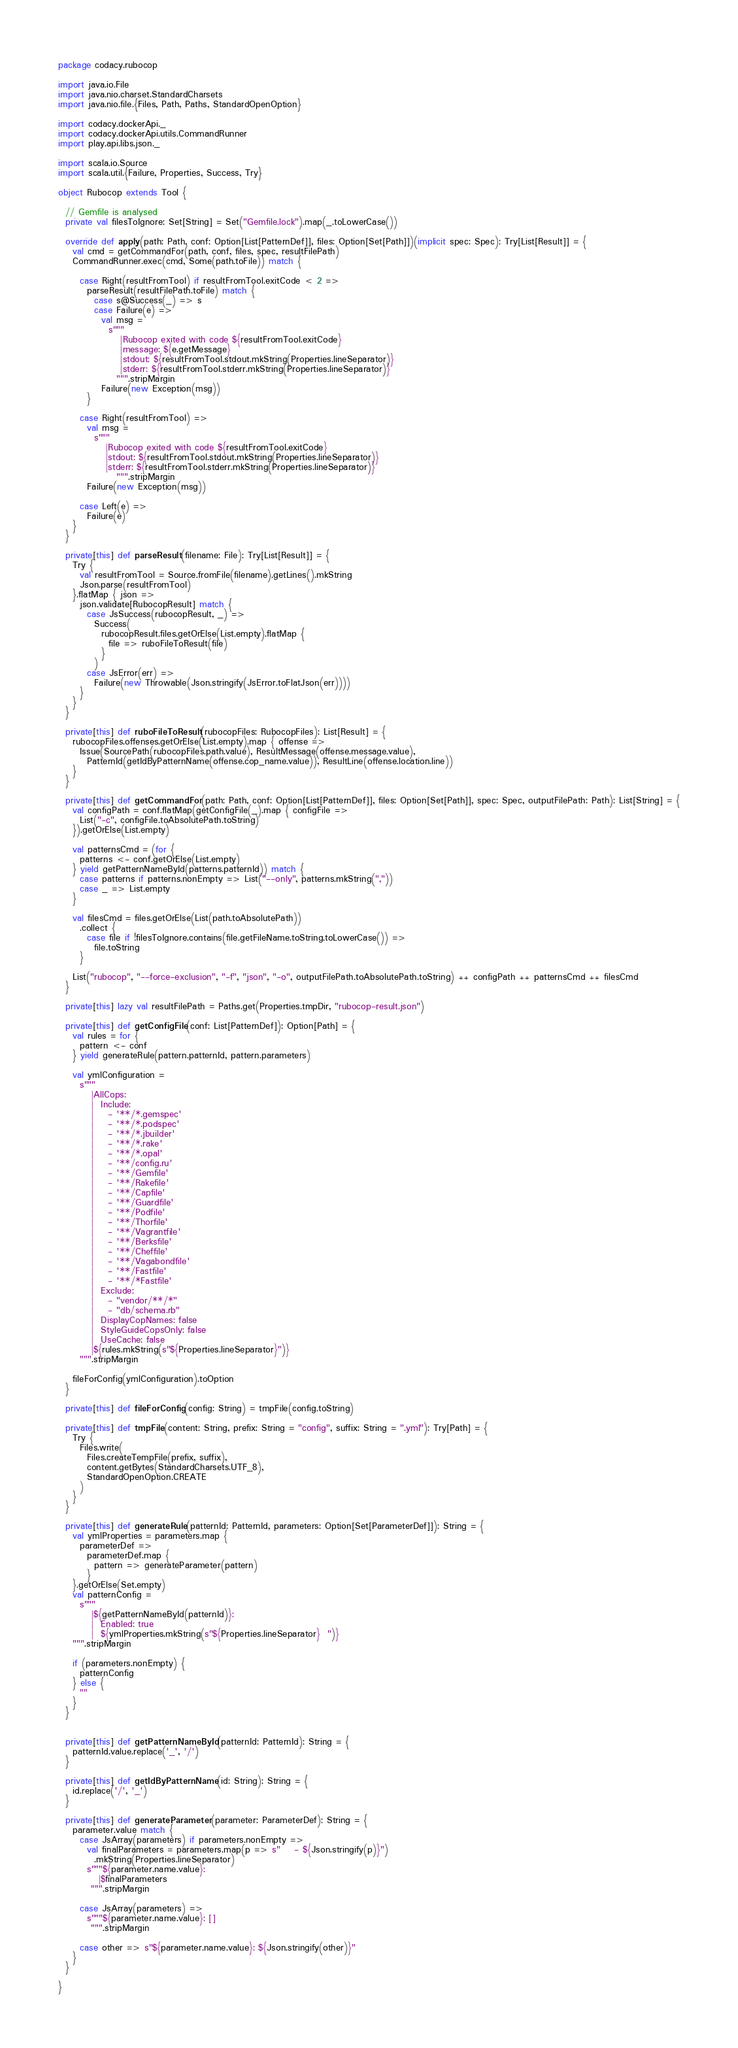Convert code to text. <code><loc_0><loc_0><loc_500><loc_500><_Scala_>package codacy.rubocop

import java.io.File
import java.nio.charset.StandardCharsets
import java.nio.file.{Files, Path, Paths, StandardOpenOption}

import codacy.dockerApi._
import codacy.dockerApi.utils.CommandRunner
import play.api.libs.json._

import scala.io.Source
import scala.util.{Failure, Properties, Success, Try}

object Rubocop extends Tool {

  // Gemfile is analysed
  private val filesToIgnore: Set[String] = Set("Gemfile.lock").map(_.toLowerCase())

  override def apply(path: Path, conf: Option[List[PatternDef]], files: Option[Set[Path]])(implicit spec: Spec): Try[List[Result]] = {
    val cmd = getCommandFor(path, conf, files, spec, resultFilePath)
    CommandRunner.exec(cmd, Some(path.toFile)) match {

      case Right(resultFromTool) if resultFromTool.exitCode < 2 =>
        parseResult(resultFilePath.toFile) match {
          case s@Success(_) => s
          case Failure(e) =>
            val msg =
              s"""
                 |Rubocop exited with code ${resultFromTool.exitCode}
                 |message: ${e.getMessage}
                 |stdout: ${resultFromTool.stdout.mkString(Properties.lineSeparator)}
                 |stderr: ${resultFromTool.stderr.mkString(Properties.lineSeparator)}
                """.stripMargin
            Failure(new Exception(msg))
        }

      case Right(resultFromTool) =>
        val msg =
          s"""
             |Rubocop exited with code ${resultFromTool.exitCode}
             |stdout: ${resultFromTool.stdout.mkString(Properties.lineSeparator)}
             |stderr: ${resultFromTool.stderr.mkString(Properties.lineSeparator)}
                """.stripMargin
        Failure(new Exception(msg))

      case Left(e) =>
        Failure(e)
    }
  }

  private[this] def parseResult(filename: File): Try[List[Result]] = {
    Try {
      val resultFromTool = Source.fromFile(filename).getLines().mkString
      Json.parse(resultFromTool)
    }.flatMap { json =>
      json.validate[RubocopResult] match {
        case JsSuccess(rubocopResult, _) =>
          Success(
            rubocopResult.files.getOrElse(List.empty).flatMap {
              file => ruboFileToResult(file)
            }
          )
        case JsError(err) =>
          Failure(new Throwable(Json.stringify(JsError.toFlatJson(err))))
      }
    }
  }

  private[this] def ruboFileToResult(rubocopFiles: RubocopFiles): List[Result] = {
    rubocopFiles.offenses.getOrElse(List.empty).map { offense =>
      Issue(SourcePath(rubocopFiles.path.value), ResultMessage(offense.message.value),
        PatternId(getIdByPatternName(offense.cop_name.value)), ResultLine(offense.location.line))
    }
  }

  private[this] def getCommandFor(path: Path, conf: Option[List[PatternDef]], files: Option[Set[Path]], spec: Spec, outputFilePath: Path): List[String] = {
    val configPath = conf.flatMap(getConfigFile(_).map { configFile =>
      List("-c", configFile.toAbsolutePath.toString)
    }).getOrElse(List.empty)

    val patternsCmd = (for {
      patterns <- conf.getOrElse(List.empty)
    } yield getPatternNameById(patterns.patternId)) match {
      case patterns if patterns.nonEmpty => List("--only", patterns.mkString(","))
      case _ => List.empty
    }

    val filesCmd = files.getOrElse(List(path.toAbsolutePath))
      .collect {
        case file if !filesToIgnore.contains(file.getFileName.toString.toLowerCase()) =>
          file.toString
      }

    List("rubocop", "--force-exclusion", "-f", "json", "-o", outputFilePath.toAbsolutePath.toString) ++ configPath ++ patternsCmd ++ filesCmd
  }

  private[this] lazy val resultFilePath = Paths.get(Properties.tmpDir, "rubocop-result.json")

  private[this] def getConfigFile(conf: List[PatternDef]): Option[Path] = {
    val rules = for {
      pattern <- conf
    } yield generateRule(pattern.patternId, pattern.parameters)

    val ymlConfiguration =
      s"""
         |AllCops:
         |  Include:
         |    - '**/*.gemspec'
         |    - '**/*.podspec'
         |    - '**/*.jbuilder'
         |    - '**/*.rake'
         |    - '**/*.opal'
         |    - '**/config.ru'
         |    - '**/Gemfile'
         |    - '**/Rakefile'
         |    - '**/Capfile'
         |    - '**/Guardfile'
         |    - '**/Podfile'
         |    - '**/Thorfile'
         |    - '**/Vagrantfile'
         |    - '**/Berksfile'
         |    - '**/Cheffile'
         |    - '**/Vagabondfile'
         |    - '**/Fastfile'
         |    - '**/*Fastfile'
         |  Exclude:
         |    - "vendor/**/*"
         |    - "db/schema.rb"
         |  DisplayCopNames: false
         |  StyleGuideCopsOnly: false
         |  UseCache: false
         |${rules.mkString(s"${Properties.lineSeparator}")}
      """.stripMargin

    fileForConfig(ymlConfiguration).toOption
  }

  private[this] def fileForConfig(config: String) = tmpFile(config.toString)

  private[this] def tmpFile(content: String, prefix: String = "config", suffix: String = ".yml"): Try[Path] = {
    Try {
      Files.write(
        Files.createTempFile(prefix, suffix),
        content.getBytes(StandardCharsets.UTF_8),
        StandardOpenOption.CREATE
      )
    }
  }

  private[this] def generateRule(patternId: PatternId, parameters: Option[Set[ParameterDef]]): String = {
    val ymlProperties = parameters.map {
      parameterDef =>
        parameterDef.map {
          pattern => generateParameter(pattern)
        }
    }.getOrElse(Set.empty)
    val patternConfig =
      s"""
         |${getPatternNameById(patternId)}:
         |  Enabled: true
         |  ${ymlProperties.mkString(s"${Properties.lineSeparator}  ")}
    """.stripMargin

    if (parameters.nonEmpty) {
      patternConfig
    } else {
      ""
    }
  }


  private[this] def getPatternNameById(patternId: PatternId): String = {
    patternId.value.replace('_', '/')
  }

  private[this] def getIdByPatternName(id: String): String = {
    id.replace('/', '_')
  }

  private[this] def generateParameter(parameter: ParameterDef): String = {
    parameter.value match {
      case JsArray(parameters) if parameters.nonEmpty =>
        val finalParameters = parameters.map(p => s"    - ${Json.stringify(p)}")
          .mkString(Properties.lineSeparator)
        s"""${parameter.name.value}:
           |$finalParameters
         """.stripMargin

      case JsArray(parameters) =>
        s"""${parameter.name.value}: []
         """.stripMargin

      case other => s"${parameter.name.value}: ${Json.stringify(other)}"
    }
  }

}
</code> 